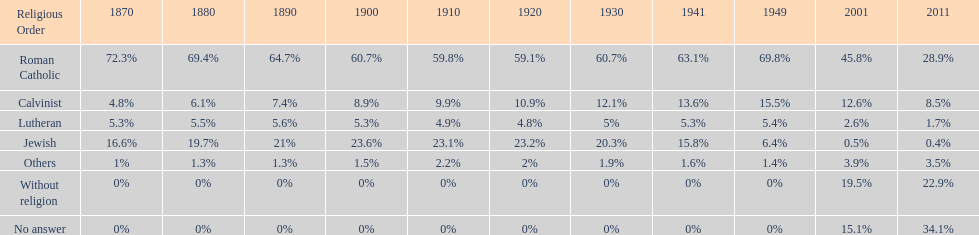The percentage of people who identified as calvinist was, at most, how much? 15.5%. 